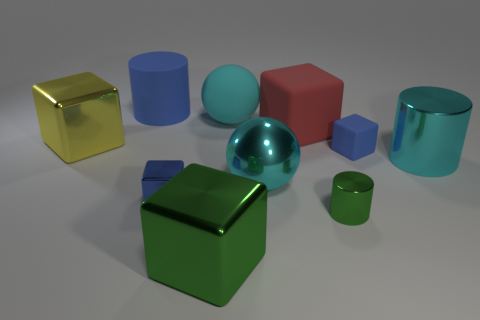Subtract all cyan balls. How many were subtracted if there are1cyan balls left? 1 Subtract all cylinders. How many objects are left? 7 Subtract all red cubes. How many cubes are left? 4 Subtract all metallic cylinders. How many cylinders are left? 1 Subtract 0 green balls. How many objects are left? 10 Subtract 3 cubes. How many cubes are left? 2 Subtract all yellow blocks. Subtract all gray spheres. How many blocks are left? 4 Subtract all purple cylinders. How many blue balls are left? 0 Subtract all rubber things. Subtract all big metal things. How many objects are left? 2 Add 9 yellow things. How many yellow things are left? 10 